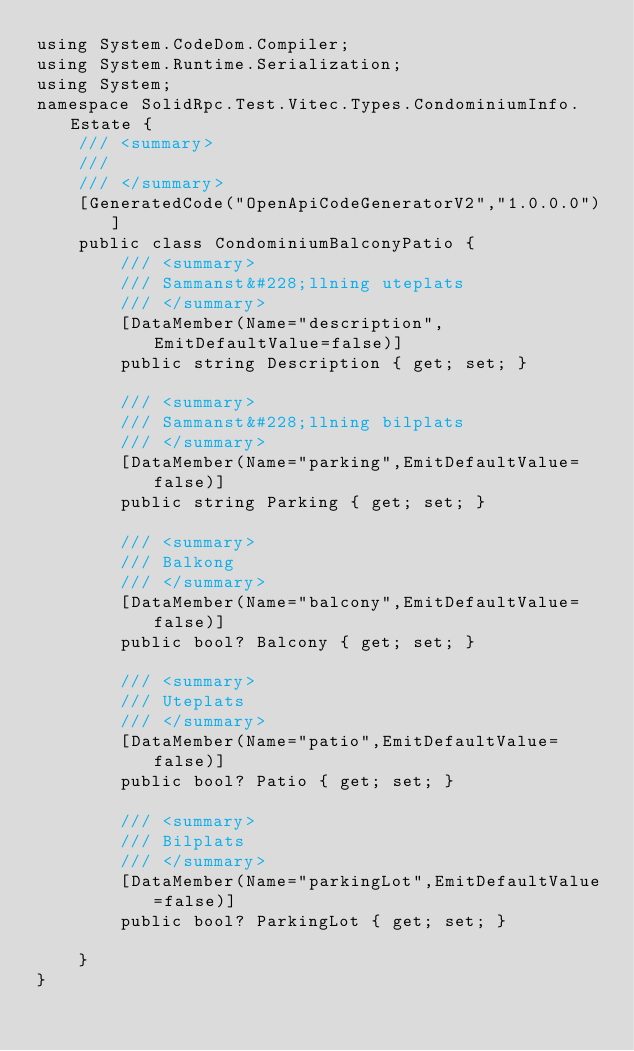Convert code to text. <code><loc_0><loc_0><loc_500><loc_500><_C#_>using System.CodeDom.Compiler;
using System.Runtime.Serialization;
using System;
namespace SolidRpc.Test.Vitec.Types.CondominiumInfo.Estate {
    /// <summary>
    /// 
    /// </summary>
    [GeneratedCode("OpenApiCodeGeneratorV2","1.0.0.0")]
    public class CondominiumBalconyPatio {
        /// <summary>
        /// Sammanst&#228;llning uteplats
        /// </summary>
        [DataMember(Name="description",EmitDefaultValue=false)]
        public string Description { get; set; }
    
        /// <summary>
        /// Sammanst&#228;llning bilplats
        /// </summary>
        [DataMember(Name="parking",EmitDefaultValue=false)]
        public string Parking { get; set; }
    
        /// <summary>
        /// Balkong
        /// </summary>
        [DataMember(Name="balcony",EmitDefaultValue=false)]
        public bool? Balcony { get; set; }
    
        /// <summary>
        /// Uteplats
        /// </summary>
        [DataMember(Name="patio",EmitDefaultValue=false)]
        public bool? Patio { get; set; }
    
        /// <summary>
        /// Bilplats
        /// </summary>
        [DataMember(Name="parkingLot",EmitDefaultValue=false)]
        public bool? ParkingLot { get; set; }
    
    }
}</code> 